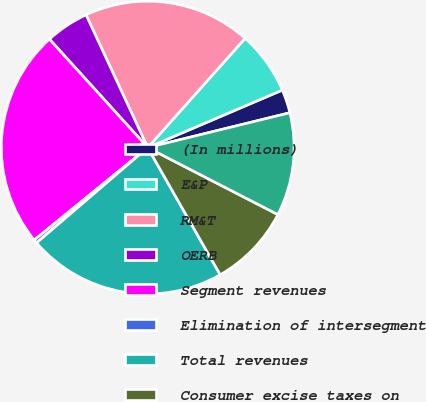Convert chart to OTSL. <chart><loc_0><loc_0><loc_500><loc_500><pie_chart><fcel>(In millions)<fcel>E&P<fcel>RM&T<fcel>OERB<fcel>Segment revenues<fcel>Elimination of intersegment<fcel>Total revenues<fcel>Consumer excise taxes on<fcel>Total buy/sell transactions<nl><fcel>2.6%<fcel>6.99%<fcel>18.51%<fcel>4.8%<fcel>24.16%<fcel>0.4%<fcel>21.97%<fcel>9.19%<fcel>11.39%<nl></chart> 